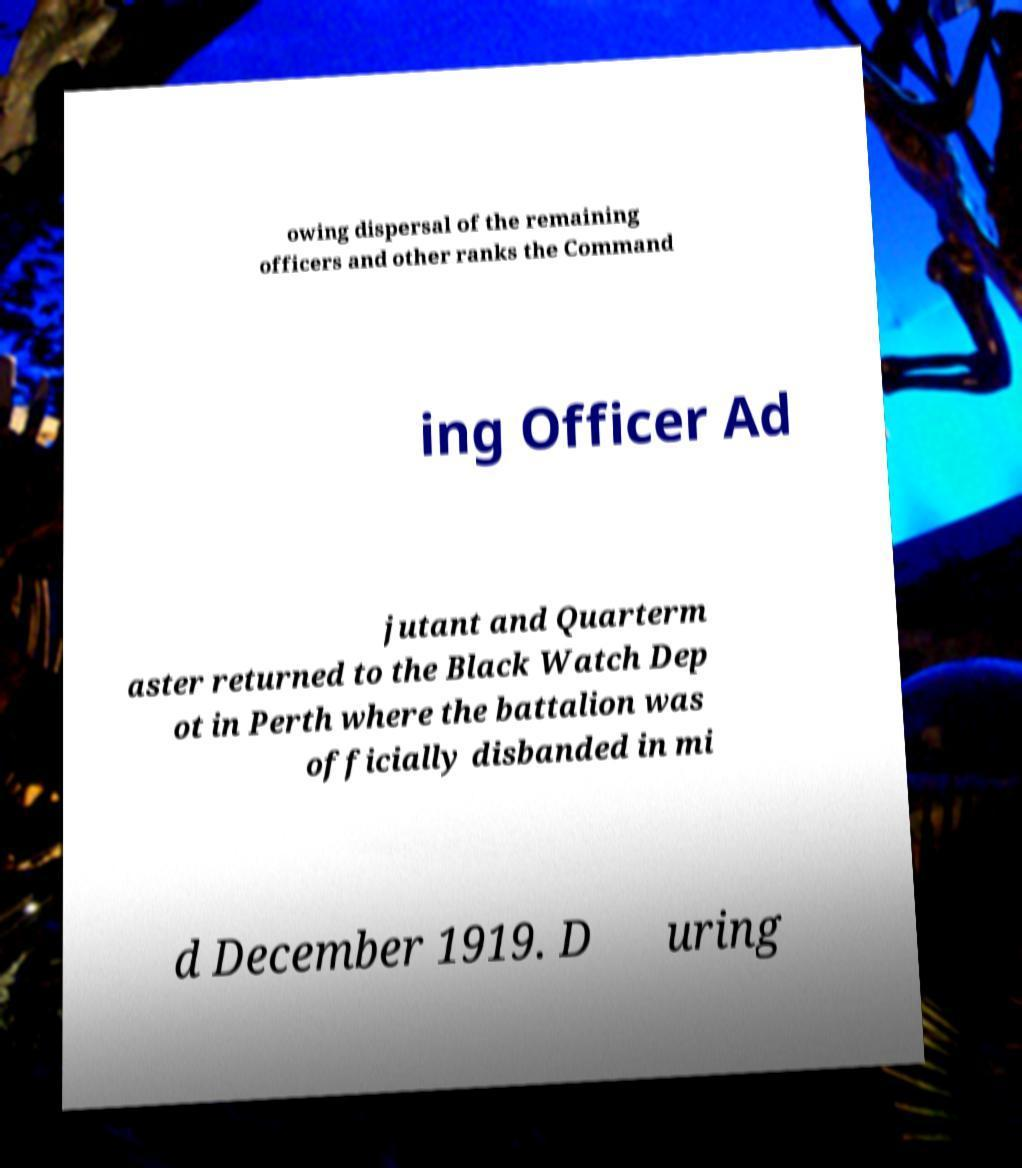Can you accurately transcribe the text from the provided image for me? owing dispersal of the remaining officers and other ranks the Command ing Officer Ad jutant and Quarterm aster returned to the Black Watch Dep ot in Perth where the battalion was officially disbanded in mi d December 1919. D uring 